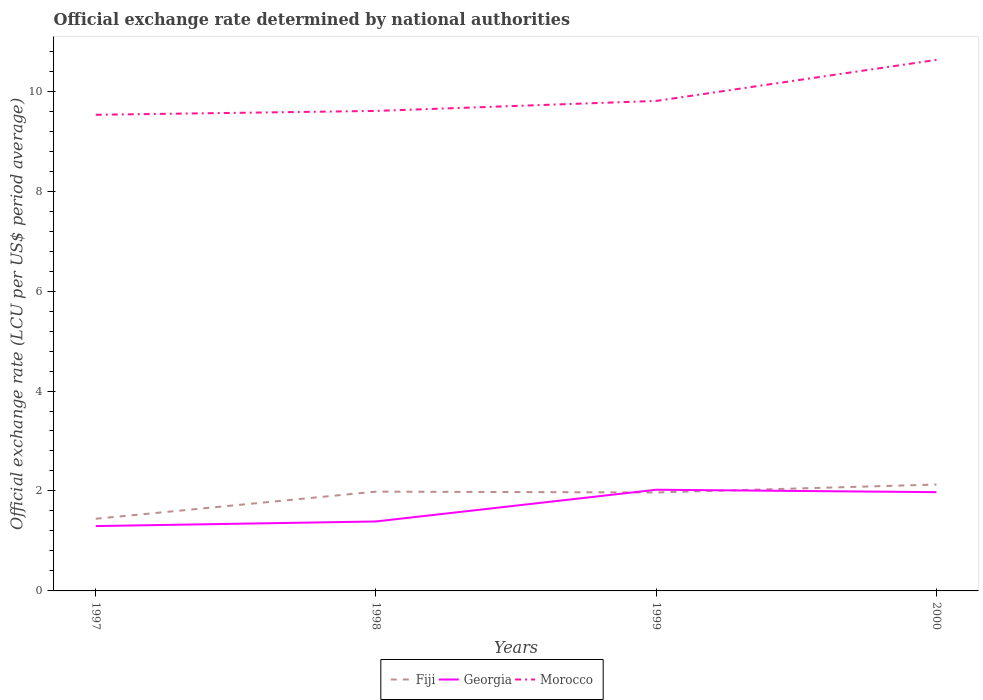Does the line corresponding to Georgia intersect with the line corresponding to Morocco?
Give a very brief answer. No. Across all years, what is the maximum official exchange rate in Fiji?
Provide a short and direct response. 1.44. What is the total official exchange rate in Fiji in the graph?
Offer a terse response. 0.02. What is the difference between the highest and the second highest official exchange rate in Fiji?
Make the answer very short. 0.68. Is the official exchange rate in Fiji strictly greater than the official exchange rate in Georgia over the years?
Your response must be concise. No. What is the difference between two consecutive major ticks on the Y-axis?
Your answer should be compact. 2. Does the graph contain any zero values?
Keep it short and to the point. No. How many legend labels are there?
Your response must be concise. 3. How are the legend labels stacked?
Your answer should be compact. Horizontal. What is the title of the graph?
Provide a succinct answer. Official exchange rate determined by national authorities. What is the label or title of the X-axis?
Provide a short and direct response. Years. What is the label or title of the Y-axis?
Your answer should be compact. Official exchange rate (LCU per US$ period average). What is the Official exchange rate (LCU per US$ period average) of Fiji in 1997?
Give a very brief answer. 1.44. What is the Official exchange rate (LCU per US$ period average) of Georgia in 1997?
Offer a very short reply. 1.3. What is the Official exchange rate (LCU per US$ period average) in Morocco in 1997?
Provide a short and direct response. 9.53. What is the Official exchange rate (LCU per US$ period average) in Fiji in 1998?
Offer a terse response. 1.99. What is the Official exchange rate (LCU per US$ period average) of Georgia in 1998?
Give a very brief answer. 1.39. What is the Official exchange rate (LCU per US$ period average) in Morocco in 1998?
Offer a terse response. 9.6. What is the Official exchange rate (LCU per US$ period average) in Fiji in 1999?
Ensure brevity in your answer.  1.97. What is the Official exchange rate (LCU per US$ period average) in Georgia in 1999?
Your answer should be compact. 2.02. What is the Official exchange rate (LCU per US$ period average) in Morocco in 1999?
Ensure brevity in your answer.  9.8. What is the Official exchange rate (LCU per US$ period average) of Fiji in 2000?
Your answer should be very brief. 2.13. What is the Official exchange rate (LCU per US$ period average) in Georgia in 2000?
Keep it short and to the point. 1.98. What is the Official exchange rate (LCU per US$ period average) in Morocco in 2000?
Offer a very short reply. 10.63. Across all years, what is the maximum Official exchange rate (LCU per US$ period average) in Fiji?
Make the answer very short. 2.13. Across all years, what is the maximum Official exchange rate (LCU per US$ period average) in Georgia?
Provide a short and direct response. 2.02. Across all years, what is the maximum Official exchange rate (LCU per US$ period average) in Morocco?
Keep it short and to the point. 10.63. Across all years, what is the minimum Official exchange rate (LCU per US$ period average) in Fiji?
Your response must be concise. 1.44. Across all years, what is the minimum Official exchange rate (LCU per US$ period average) of Georgia?
Your answer should be very brief. 1.3. Across all years, what is the minimum Official exchange rate (LCU per US$ period average) in Morocco?
Your answer should be compact. 9.53. What is the total Official exchange rate (LCU per US$ period average) in Fiji in the graph?
Your answer should be very brief. 7.53. What is the total Official exchange rate (LCU per US$ period average) of Georgia in the graph?
Your response must be concise. 6.69. What is the total Official exchange rate (LCU per US$ period average) in Morocco in the graph?
Keep it short and to the point. 39.56. What is the difference between the Official exchange rate (LCU per US$ period average) of Fiji in 1997 and that in 1998?
Your answer should be very brief. -0.54. What is the difference between the Official exchange rate (LCU per US$ period average) in Georgia in 1997 and that in 1998?
Make the answer very short. -0.09. What is the difference between the Official exchange rate (LCU per US$ period average) in Morocco in 1997 and that in 1998?
Your answer should be very brief. -0.08. What is the difference between the Official exchange rate (LCU per US$ period average) of Fiji in 1997 and that in 1999?
Your response must be concise. -0.53. What is the difference between the Official exchange rate (LCU per US$ period average) in Georgia in 1997 and that in 1999?
Make the answer very short. -0.73. What is the difference between the Official exchange rate (LCU per US$ period average) of Morocco in 1997 and that in 1999?
Provide a short and direct response. -0.28. What is the difference between the Official exchange rate (LCU per US$ period average) in Fiji in 1997 and that in 2000?
Offer a terse response. -0.68. What is the difference between the Official exchange rate (LCU per US$ period average) in Georgia in 1997 and that in 2000?
Provide a short and direct response. -0.68. What is the difference between the Official exchange rate (LCU per US$ period average) of Morocco in 1997 and that in 2000?
Make the answer very short. -1.1. What is the difference between the Official exchange rate (LCU per US$ period average) in Fiji in 1998 and that in 1999?
Ensure brevity in your answer.  0.02. What is the difference between the Official exchange rate (LCU per US$ period average) in Georgia in 1998 and that in 1999?
Your response must be concise. -0.63. What is the difference between the Official exchange rate (LCU per US$ period average) in Morocco in 1998 and that in 1999?
Give a very brief answer. -0.2. What is the difference between the Official exchange rate (LCU per US$ period average) in Fiji in 1998 and that in 2000?
Your answer should be compact. -0.14. What is the difference between the Official exchange rate (LCU per US$ period average) of Georgia in 1998 and that in 2000?
Ensure brevity in your answer.  -0.59. What is the difference between the Official exchange rate (LCU per US$ period average) of Morocco in 1998 and that in 2000?
Your answer should be very brief. -1.02. What is the difference between the Official exchange rate (LCU per US$ period average) in Fiji in 1999 and that in 2000?
Provide a succinct answer. -0.16. What is the difference between the Official exchange rate (LCU per US$ period average) of Georgia in 1999 and that in 2000?
Your answer should be compact. 0.05. What is the difference between the Official exchange rate (LCU per US$ period average) of Morocco in 1999 and that in 2000?
Give a very brief answer. -0.82. What is the difference between the Official exchange rate (LCU per US$ period average) in Fiji in 1997 and the Official exchange rate (LCU per US$ period average) in Georgia in 1998?
Make the answer very short. 0.05. What is the difference between the Official exchange rate (LCU per US$ period average) in Fiji in 1997 and the Official exchange rate (LCU per US$ period average) in Morocco in 1998?
Keep it short and to the point. -8.16. What is the difference between the Official exchange rate (LCU per US$ period average) of Georgia in 1997 and the Official exchange rate (LCU per US$ period average) of Morocco in 1998?
Offer a terse response. -8.31. What is the difference between the Official exchange rate (LCU per US$ period average) in Fiji in 1997 and the Official exchange rate (LCU per US$ period average) in Georgia in 1999?
Ensure brevity in your answer.  -0.58. What is the difference between the Official exchange rate (LCU per US$ period average) of Fiji in 1997 and the Official exchange rate (LCU per US$ period average) of Morocco in 1999?
Give a very brief answer. -8.36. What is the difference between the Official exchange rate (LCU per US$ period average) in Georgia in 1997 and the Official exchange rate (LCU per US$ period average) in Morocco in 1999?
Offer a terse response. -8.51. What is the difference between the Official exchange rate (LCU per US$ period average) of Fiji in 1997 and the Official exchange rate (LCU per US$ period average) of Georgia in 2000?
Make the answer very short. -0.53. What is the difference between the Official exchange rate (LCU per US$ period average) in Fiji in 1997 and the Official exchange rate (LCU per US$ period average) in Morocco in 2000?
Your answer should be compact. -9.18. What is the difference between the Official exchange rate (LCU per US$ period average) in Georgia in 1997 and the Official exchange rate (LCU per US$ period average) in Morocco in 2000?
Make the answer very short. -9.33. What is the difference between the Official exchange rate (LCU per US$ period average) of Fiji in 1998 and the Official exchange rate (LCU per US$ period average) of Georgia in 1999?
Offer a very short reply. -0.04. What is the difference between the Official exchange rate (LCU per US$ period average) in Fiji in 1998 and the Official exchange rate (LCU per US$ period average) in Morocco in 1999?
Your answer should be compact. -7.82. What is the difference between the Official exchange rate (LCU per US$ period average) of Georgia in 1998 and the Official exchange rate (LCU per US$ period average) of Morocco in 1999?
Provide a short and direct response. -8.41. What is the difference between the Official exchange rate (LCU per US$ period average) in Fiji in 1998 and the Official exchange rate (LCU per US$ period average) in Georgia in 2000?
Provide a short and direct response. 0.01. What is the difference between the Official exchange rate (LCU per US$ period average) in Fiji in 1998 and the Official exchange rate (LCU per US$ period average) in Morocco in 2000?
Make the answer very short. -8.64. What is the difference between the Official exchange rate (LCU per US$ period average) in Georgia in 1998 and the Official exchange rate (LCU per US$ period average) in Morocco in 2000?
Offer a terse response. -9.24. What is the difference between the Official exchange rate (LCU per US$ period average) in Fiji in 1999 and the Official exchange rate (LCU per US$ period average) in Georgia in 2000?
Keep it short and to the point. -0.01. What is the difference between the Official exchange rate (LCU per US$ period average) in Fiji in 1999 and the Official exchange rate (LCU per US$ period average) in Morocco in 2000?
Make the answer very short. -8.66. What is the difference between the Official exchange rate (LCU per US$ period average) of Georgia in 1999 and the Official exchange rate (LCU per US$ period average) of Morocco in 2000?
Offer a terse response. -8.6. What is the average Official exchange rate (LCU per US$ period average) of Fiji per year?
Ensure brevity in your answer.  1.88. What is the average Official exchange rate (LCU per US$ period average) in Georgia per year?
Provide a short and direct response. 1.67. What is the average Official exchange rate (LCU per US$ period average) in Morocco per year?
Make the answer very short. 9.89. In the year 1997, what is the difference between the Official exchange rate (LCU per US$ period average) in Fiji and Official exchange rate (LCU per US$ period average) in Georgia?
Offer a terse response. 0.15. In the year 1997, what is the difference between the Official exchange rate (LCU per US$ period average) of Fiji and Official exchange rate (LCU per US$ period average) of Morocco?
Your answer should be very brief. -8.08. In the year 1997, what is the difference between the Official exchange rate (LCU per US$ period average) in Georgia and Official exchange rate (LCU per US$ period average) in Morocco?
Provide a succinct answer. -8.23. In the year 1998, what is the difference between the Official exchange rate (LCU per US$ period average) in Fiji and Official exchange rate (LCU per US$ period average) in Georgia?
Offer a terse response. 0.6. In the year 1998, what is the difference between the Official exchange rate (LCU per US$ period average) in Fiji and Official exchange rate (LCU per US$ period average) in Morocco?
Offer a very short reply. -7.62. In the year 1998, what is the difference between the Official exchange rate (LCU per US$ period average) in Georgia and Official exchange rate (LCU per US$ period average) in Morocco?
Keep it short and to the point. -8.21. In the year 1999, what is the difference between the Official exchange rate (LCU per US$ period average) in Fiji and Official exchange rate (LCU per US$ period average) in Georgia?
Give a very brief answer. -0.05. In the year 1999, what is the difference between the Official exchange rate (LCU per US$ period average) in Fiji and Official exchange rate (LCU per US$ period average) in Morocco?
Provide a short and direct response. -7.83. In the year 1999, what is the difference between the Official exchange rate (LCU per US$ period average) in Georgia and Official exchange rate (LCU per US$ period average) in Morocco?
Provide a succinct answer. -7.78. In the year 2000, what is the difference between the Official exchange rate (LCU per US$ period average) in Fiji and Official exchange rate (LCU per US$ period average) in Georgia?
Your response must be concise. 0.15. In the year 2000, what is the difference between the Official exchange rate (LCU per US$ period average) of Fiji and Official exchange rate (LCU per US$ period average) of Morocco?
Make the answer very short. -8.5. In the year 2000, what is the difference between the Official exchange rate (LCU per US$ period average) of Georgia and Official exchange rate (LCU per US$ period average) of Morocco?
Give a very brief answer. -8.65. What is the ratio of the Official exchange rate (LCU per US$ period average) of Fiji in 1997 to that in 1998?
Give a very brief answer. 0.73. What is the ratio of the Official exchange rate (LCU per US$ period average) in Georgia in 1997 to that in 1998?
Give a very brief answer. 0.93. What is the ratio of the Official exchange rate (LCU per US$ period average) of Morocco in 1997 to that in 1998?
Your answer should be compact. 0.99. What is the ratio of the Official exchange rate (LCU per US$ period average) of Fiji in 1997 to that in 1999?
Keep it short and to the point. 0.73. What is the ratio of the Official exchange rate (LCU per US$ period average) in Georgia in 1997 to that in 1999?
Provide a succinct answer. 0.64. What is the ratio of the Official exchange rate (LCU per US$ period average) in Morocco in 1997 to that in 1999?
Your response must be concise. 0.97. What is the ratio of the Official exchange rate (LCU per US$ period average) in Fiji in 1997 to that in 2000?
Provide a succinct answer. 0.68. What is the ratio of the Official exchange rate (LCU per US$ period average) of Georgia in 1997 to that in 2000?
Your answer should be compact. 0.66. What is the ratio of the Official exchange rate (LCU per US$ period average) in Morocco in 1997 to that in 2000?
Offer a very short reply. 0.9. What is the ratio of the Official exchange rate (LCU per US$ period average) in Fiji in 1998 to that in 1999?
Your response must be concise. 1.01. What is the ratio of the Official exchange rate (LCU per US$ period average) of Georgia in 1998 to that in 1999?
Offer a very short reply. 0.69. What is the ratio of the Official exchange rate (LCU per US$ period average) of Morocco in 1998 to that in 1999?
Keep it short and to the point. 0.98. What is the ratio of the Official exchange rate (LCU per US$ period average) in Fiji in 1998 to that in 2000?
Offer a terse response. 0.93. What is the ratio of the Official exchange rate (LCU per US$ period average) of Georgia in 1998 to that in 2000?
Make the answer very short. 0.7. What is the ratio of the Official exchange rate (LCU per US$ period average) of Morocco in 1998 to that in 2000?
Keep it short and to the point. 0.9. What is the ratio of the Official exchange rate (LCU per US$ period average) of Fiji in 1999 to that in 2000?
Offer a very short reply. 0.93. What is the ratio of the Official exchange rate (LCU per US$ period average) in Georgia in 1999 to that in 2000?
Provide a succinct answer. 1.02. What is the ratio of the Official exchange rate (LCU per US$ period average) of Morocco in 1999 to that in 2000?
Offer a very short reply. 0.92. What is the difference between the highest and the second highest Official exchange rate (LCU per US$ period average) in Fiji?
Make the answer very short. 0.14. What is the difference between the highest and the second highest Official exchange rate (LCU per US$ period average) in Georgia?
Offer a terse response. 0.05. What is the difference between the highest and the second highest Official exchange rate (LCU per US$ period average) in Morocco?
Provide a succinct answer. 0.82. What is the difference between the highest and the lowest Official exchange rate (LCU per US$ period average) in Fiji?
Your answer should be compact. 0.68. What is the difference between the highest and the lowest Official exchange rate (LCU per US$ period average) in Georgia?
Your response must be concise. 0.73. What is the difference between the highest and the lowest Official exchange rate (LCU per US$ period average) in Morocco?
Provide a succinct answer. 1.1. 